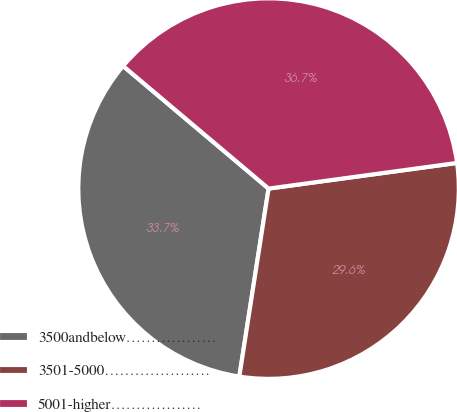Convert chart to OTSL. <chart><loc_0><loc_0><loc_500><loc_500><pie_chart><fcel>3500andbelow………………<fcel>3501-5000…………………<fcel>5001-higher………………<nl><fcel>33.69%<fcel>29.61%<fcel>36.7%<nl></chart> 